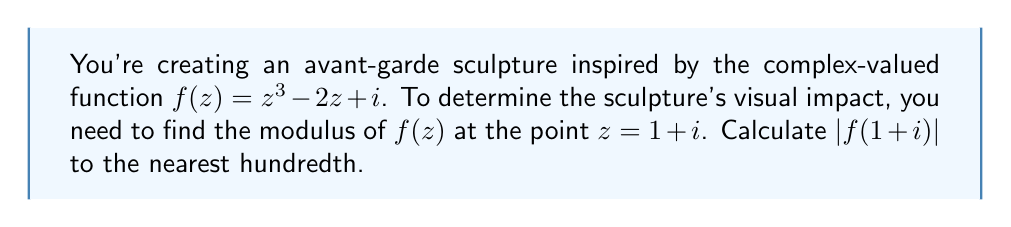Can you solve this math problem? Let's approach this step-by-step:

1) We start with the function $f(z) = z^3 - 2z + i$

2) We need to evaluate this at $z = 1+i$:
   
   $f(1+i) = (1+i)^3 - 2(1+i) + i$

3) Let's expand $(1+i)^3$:
   $(1+i)^3 = (1+i)^2(1+i) = (1+2i-1)(1+i) = 2i(1+i) = 2i + 2i^2 = 2i - 2$

4) Now our expression becomes:
   $f(1+i) = (2i - 2) - 2(1+i) + i$
           $= 2i - 2 - 2 - 2i + i$
           $= -4 + i$

5) To find the modulus, we use the formula $|a+bi| = \sqrt{a^2 + b^2}$:
   
   $|f(1+i)| = |-4 + i| = \sqrt{(-4)^2 + 1^2} = \sqrt{16 + 1} = \sqrt{17}$

6) $\sqrt{17} \approx 4.12310562561766$

7) Rounding to the nearest hundredth gives us 4.12.
Answer: 4.12 